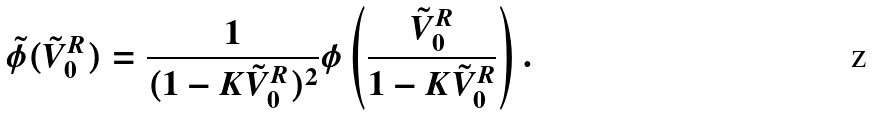Convert formula to latex. <formula><loc_0><loc_0><loc_500><loc_500>\tilde { \phi } ( \tilde { V } _ { 0 } ^ { R } ) = \frac { 1 } { ( 1 - K \tilde { V } _ { 0 } ^ { R } ) ^ { 2 } } \phi \left ( \frac { \tilde { V } _ { 0 } ^ { R } } { 1 - K \tilde { V } _ { 0 } ^ { R } } \right ) .</formula> 